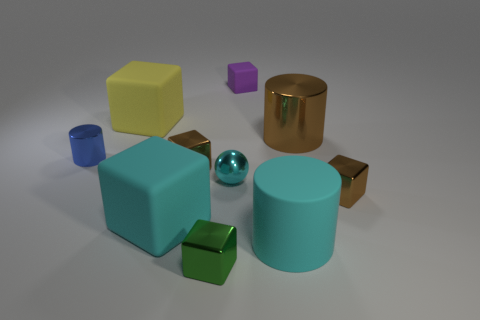Subtract all tiny cylinders. How many cylinders are left? 2 Add 3 big objects. How many big objects exist? 7 Subtract all brown cubes. How many cubes are left? 4 Subtract 0 brown spheres. How many objects are left? 10 Subtract all spheres. How many objects are left? 9 Subtract 3 cylinders. How many cylinders are left? 0 Subtract all gray cubes. Subtract all red balls. How many cubes are left? 6 Subtract all green balls. How many brown cubes are left? 2 Subtract all matte cylinders. Subtract all big rubber things. How many objects are left? 6 Add 4 large yellow rubber cubes. How many large yellow rubber cubes are left? 5 